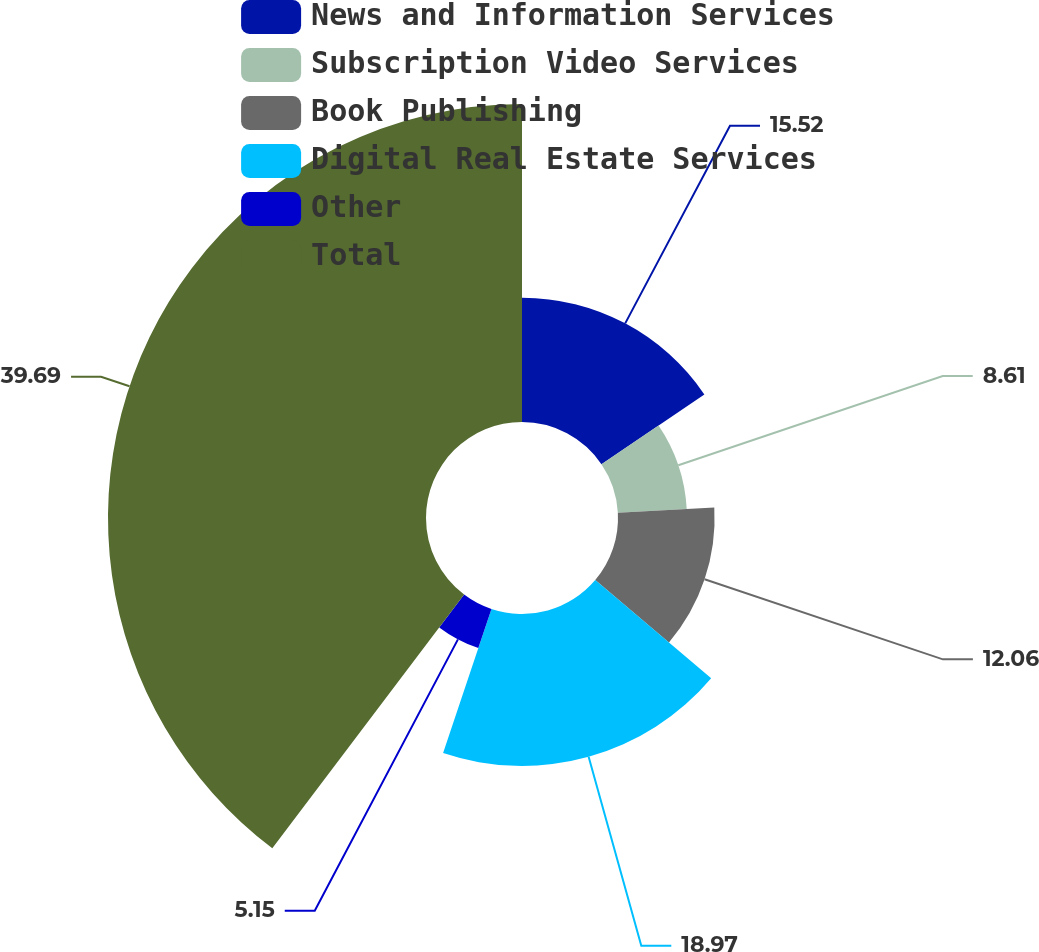Convert chart to OTSL. <chart><loc_0><loc_0><loc_500><loc_500><pie_chart><fcel>News and Information Services<fcel>Subscription Video Services<fcel>Book Publishing<fcel>Digital Real Estate Services<fcel>Other<fcel>Total<nl><fcel>15.52%<fcel>8.61%<fcel>12.06%<fcel>18.97%<fcel>5.15%<fcel>39.7%<nl></chart> 